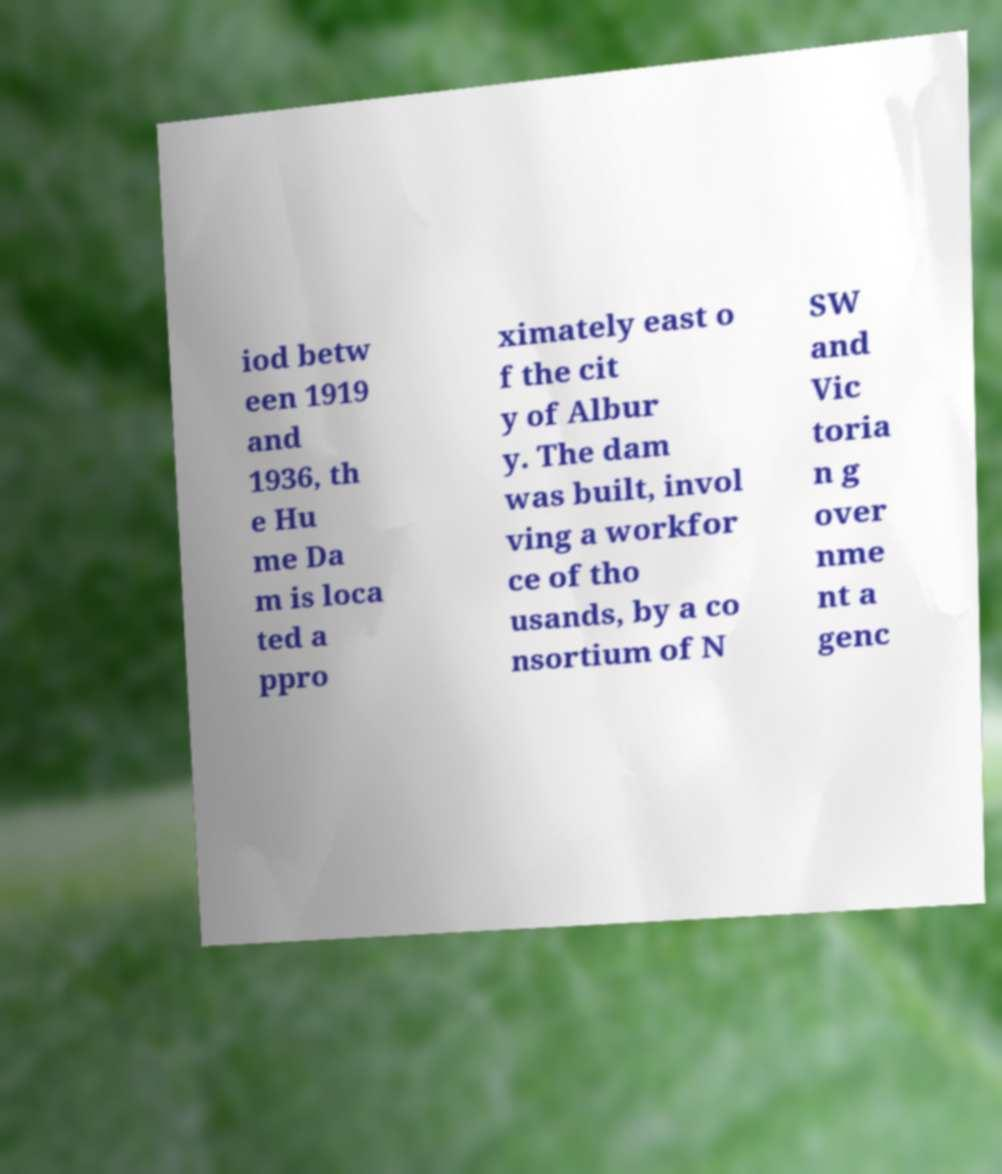For documentation purposes, I need the text within this image transcribed. Could you provide that? iod betw een 1919 and 1936, th e Hu me Da m is loca ted a ppro ximately east o f the cit y of Albur y. The dam was built, invol ving a workfor ce of tho usands, by a co nsortium of N SW and Vic toria n g over nme nt a genc 